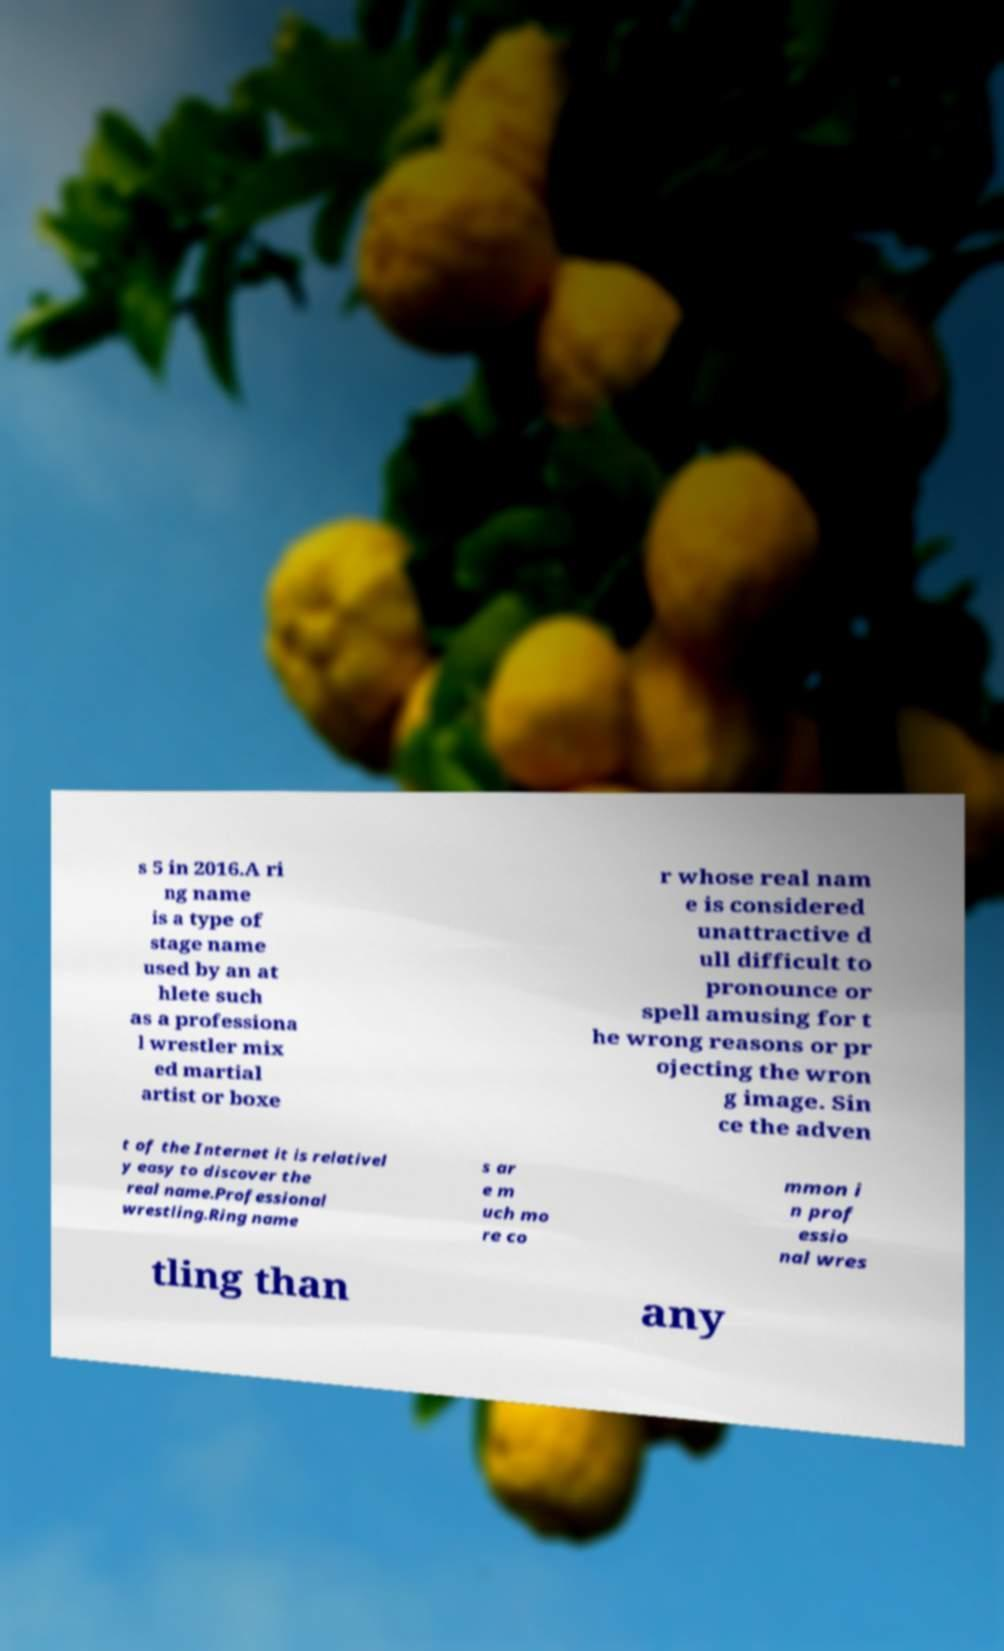There's text embedded in this image that I need extracted. Can you transcribe it verbatim? s 5 in 2016.A ri ng name is a type of stage name used by an at hlete such as a professiona l wrestler mix ed martial artist or boxe r whose real nam e is considered unattractive d ull difficult to pronounce or spell amusing for t he wrong reasons or pr ojecting the wron g image. Sin ce the adven t of the Internet it is relativel y easy to discover the real name.Professional wrestling.Ring name s ar e m uch mo re co mmon i n prof essio nal wres tling than any 